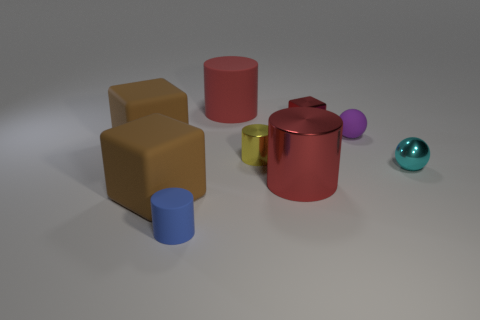How many red cylinders must be subtracted to get 1 red cylinders? 1 Subtract all blue cylinders. How many brown cubes are left? 2 Subtract all big brown rubber blocks. How many blocks are left? 1 Subtract all blue cylinders. How many cylinders are left? 3 Subtract 2 cylinders. How many cylinders are left? 2 Subtract all green cylinders. Subtract all blue balls. How many cylinders are left? 4 Subtract all blocks. How many objects are left? 6 Add 5 tiny yellow metallic things. How many tiny yellow metallic things are left? 6 Add 5 small red metal objects. How many small red metal objects exist? 6 Subtract 1 red cylinders. How many objects are left? 8 